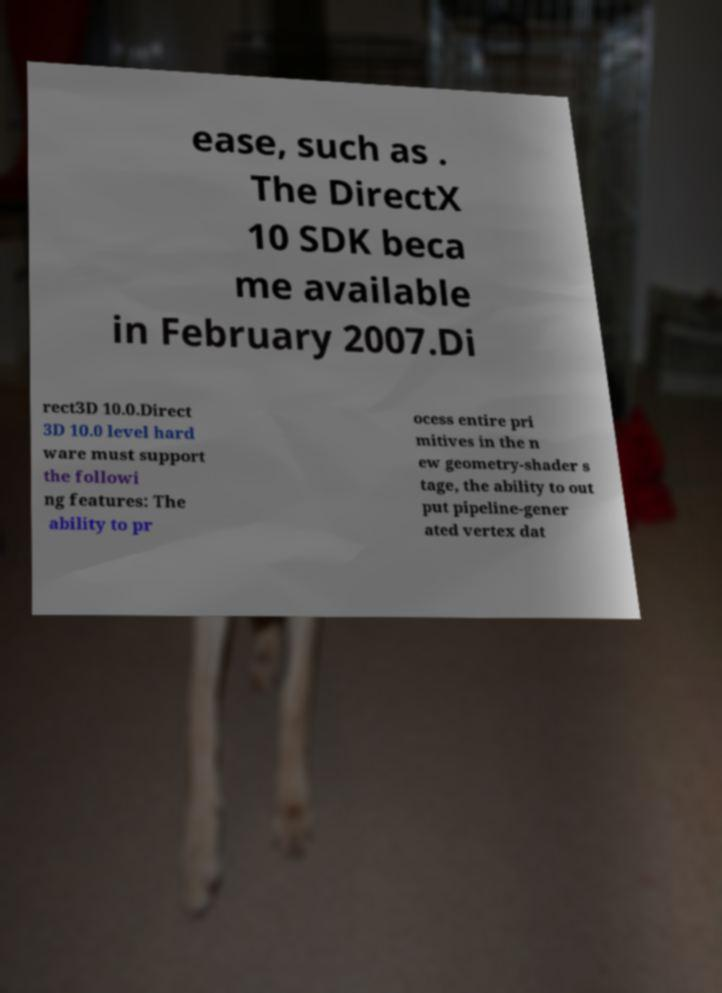Please read and relay the text visible in this image. What does it say? ease, such as . The DirectX 10 SDK beca me available in February 2007.Di rect3D 10.0.Direct 3D 10.0 level hard ware must support the followi ng features: The ability to pr ocess entire pri mitives in the n ew geometry-shader s tage, the ability to out put pipeline-gener ated vertex dat 